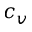Convert formula to latex. <formula><loc_0><loc_0><loc_500><loc_500>c _ { v }</formula> 